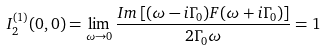<formula> <loc_0><loc_0><loc_500><loc_500>I ^ { ( 1 ) } _ { 2 } ( 0 , 0 ) = \lim _ { \omega \rightarrow 0 } \frac { I m \left [ ( \omega - i \Gamma _ { 0 } ) F ( \omega + i \Gamma _ { 0 } ) \right ] } { 2 \Gamma _ { 0 } \omega } = 1</formula> 